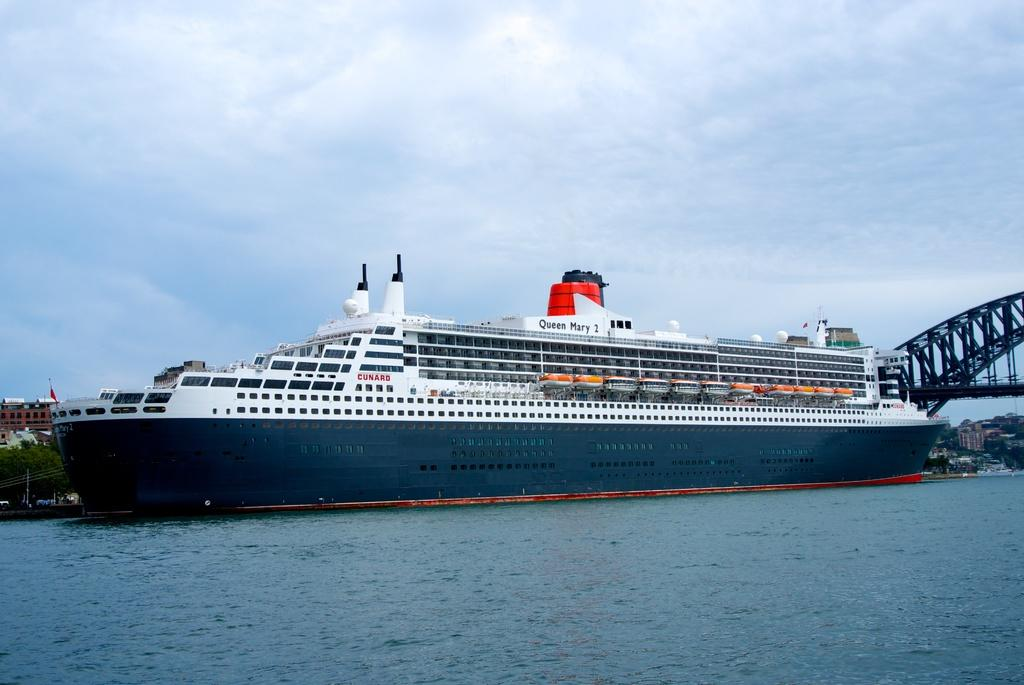What is the main subject of the image? The main subject of the image is a big cruise ship. Can you describe the color of the cruise ship? The cruise ship is white and blue in color. Where is the cruise ship located in the image? The cruise ship is in the water. What can be seen in the background of the image? There is a metal bridge visible in the background. How would you describe the sky in the image? The sky is blue in the image, and there are clouds present. What type of nose is visible on the cruise ship in the image? There is no nose present on the cruise ship in the image; it is a large vessel for transportation and leisure. 